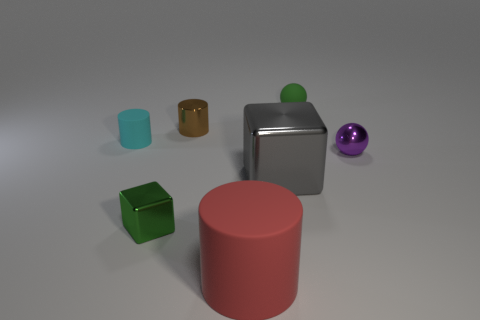The cyan cylinder that is the same material as the red cylinder is what size?
Offer a very short reply. Small. There is a green thing that is in front of the cyan matte cylinder; is it the same size as the big red cylinder?
Give a very brief answer. No. There is a tiny metallic object that is behind the tiny ball that is in front of the small sphere that is left of the tiny purple ball; what is its shape?
Provide a succinct answer. Cylinder. How many things are tiny purple spheres or small green objects in front of the tiny matte cylinder?
Offer a terse response. 2. There is a object behind the tiny brown cylinder; what size is it?
Offer a very short reply. Small. There is a thing that is the same color as the small metal cube; what shape is it?
Keep it short and to the point. Sphere. Does the big gray object have the same material as the small ball in front of the tiny cyan object?
Give a very brief answer. Yes. How many large things are behind the cylinder that is in front of the block that is left of the large cube?
Offer a very short reply. 1. What number of brown objects are either big matte cylinders or matte objects?
Your response must be concise. 0. There is a green thing to the right of the tiny cube; what shape is it?
Ensure brevity in your answer.  Sphere. 